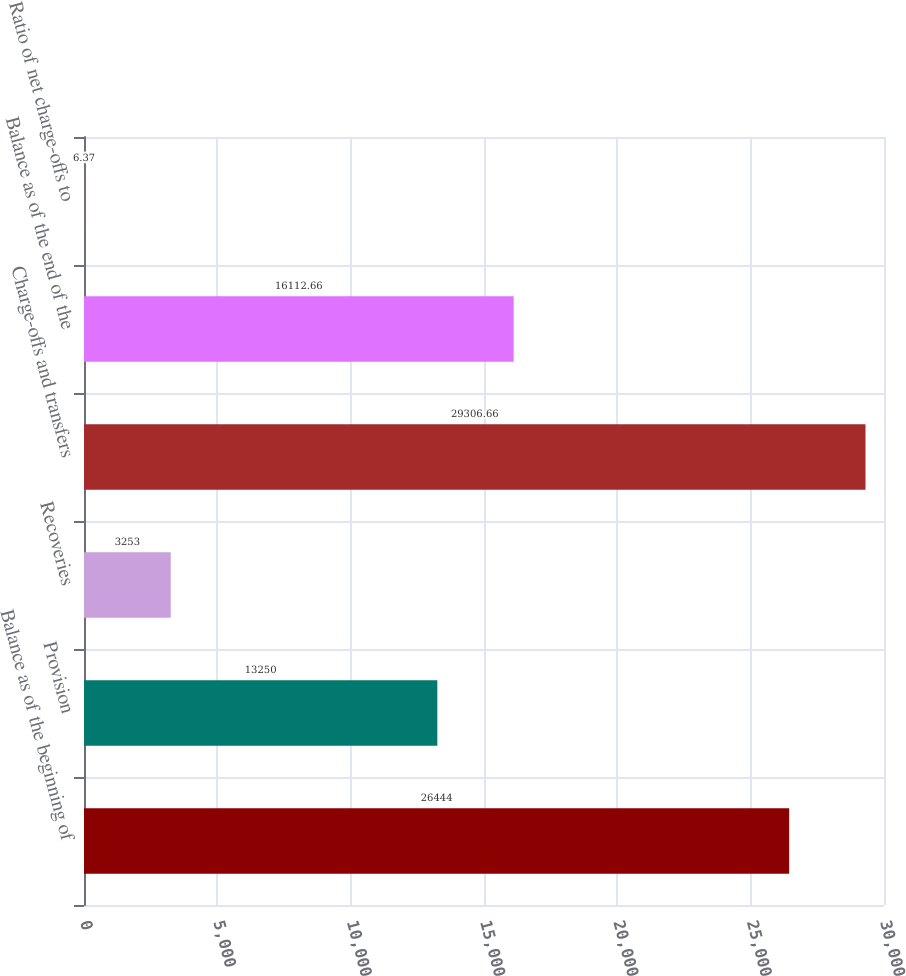<chart> <loc_0><loc_0><loc_500><loc_500><bar_chart><fcel>Balance as of the beginning of<fcel>Provision<fcel>Recoveries<fcel>Charge-offs and transfers<fcel>Balance as of the end of the<fcel>Ratio of net charge-offs to<nl><fcel>26444<fcel>13250<fcel>3253<fcel>29306.7<fcel>16112.7<fcel>6.37<nl></chart> 